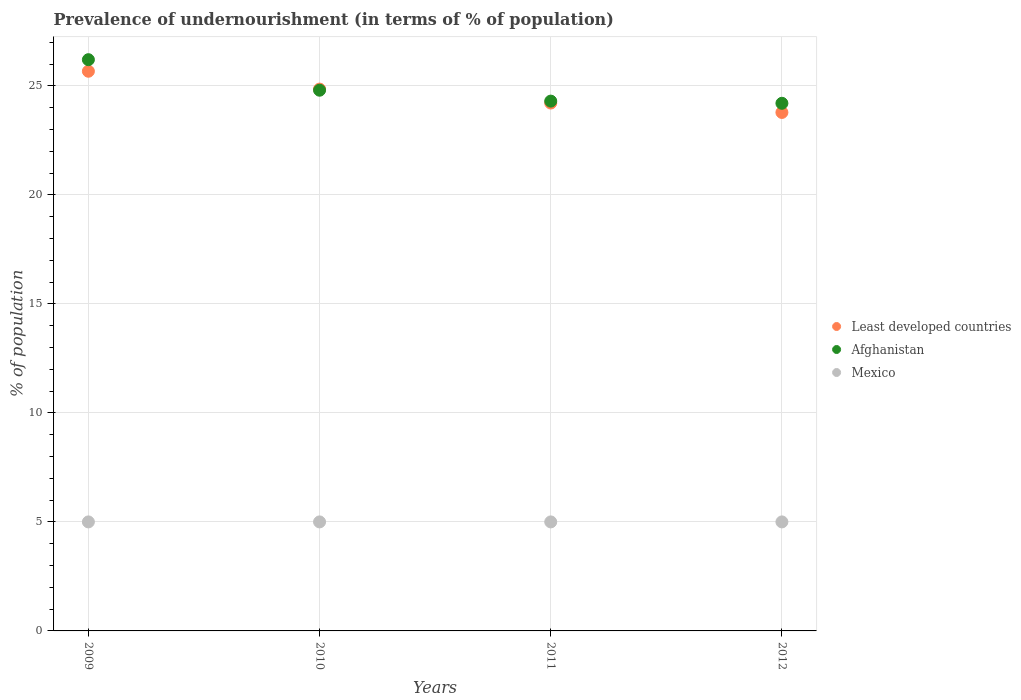How many different coloured dotlines are there?
Keep it short and to the point. 3. Is the number of dotlines equal to the number of legend labels?
Your answer should be very brief. Yes. Across all years, what is the maximum percentage of undernourished population in Mexico?
Make the answer very short. 5. Across all years, what is the minimum percentage of undernourished population in Least developed countries?
Provide a short and direct response. 23.78. In which year was the percentage of undernourished population in Mexico maximum?
Offer a terse response. 2009. In which year was the percentage of undernourished population in Afghanistan minimum?
Your answer should be very brief. 2012. What is the total percentage of undernourished population in Mexico in the graph?
Your answer should be compact. 20. What is the difference between the percentage of undernourished population in Mexico in 2009 and that in 2011?
Your response must be concise. 0. What is the difference between the percentage of undernourished population in Afghanistan in 2010 and the percentage of undernourished population in Least developed countries in 2009?
Offer a terse response. -0.87. What is the average percentage of undernourished population in Afghanistan per year?
Offer a terse response. 24.88. In the year 2009, what is the difference between the percentage of undernourished population in Afghanistan and percentage of undernourished population in Least developed countries?
Give a very brief answer. 0.53. In how many years, is the percentage of undernourished population in Mexico greater than 3 %?
Your answer should be very brief. 4. What is the ratio of the percentage of undernourished population in Afghanistan in 2011 to that in 2012?
Ensure brevity in your answer.  1. What is the difference between the highest and the second highest percentage of undernourished population in Least developed countries?
Offer a terse response. 0.82. What is the difference between the highest and the lowest percentage of undernourished population in Afghanistan?
Provide a succinct answer. 2. In how many years, is the percentage of undernourished population in Mexico greater than the average percentage of undernourished population in Mexico taken over all years?
Your answer should be compact. 0. Is it the case that in every year, the sum of the percentage of undernourished population in Least developed countries and percentage of undernourished population in Mexico  is greater than the percentage of undernourished population in Afghanistan?
Your response must be concise. Yes. Is the percentage of undernourished population in Mexico strictly greater than the percentage of undernourished population in Least developed countries over the years?
Offer a very short reply. No. How many years are there in the graph?
Provide a short and direct response. 4. Are the values on the major ticks of Y-axis written in scientific E-notation?
Ensure brevity in your answer.  No. Where does the legend appear in the graph?
Make the answer very short. Center right. How many legend labels are there?
Provide a succinct answer. 3. What is the title of the graph?
Offer a terse response. Prevalence of undernourishment (in terms of % of population). What is the label or title of the X-axis?
Offer a terse response. Years. What is the label or title of the Y-axis?
Provide a short and direct response. % of population. What is the % of population of Least developed countries in 2009?
Offer a terse response. 25.67. What is the % of population of Afghanistan in 2009?
Provide a succinct answer. 26.2. What is the % of population of Least developed countries in 2010?
Your response must be concise. 24.85. What is the % of population of Afghanistan in 2010?
Your answer should be compact. 24.8. What is the % of population in Mexico in 2010?
Offer a terse response. 5. What is the % of population of Least developed countries in 2011?
Give a very brief answer. 24.21. What is the % of population of Afghanistan in 2011?
Offer a terse response. 24.3. What is the % of population in Mexico in 2011?
Make the answer very short. 5. What is the % of population of Least developed countries in 2012?
Ensure brevity in your answer.  23.78. What is the % of population in Afghanistan in 2012?
Your response must be concise. 24.2. What is the % of population in Mexico in 2012?
Your answer should be compact. 5. Across all years, what is the maximum % of population of Least developed countries?
Provide a short and direct response. 25.67. Across all years, what is the maximum % of population of Afghanistan?
Your answer should be compact. 26.2. Across all years, what is the maximum % of population of Mexico?
Make the answer very short. 5. Across all years, what is the minimum % of population in Least developed countries?
Offer a terse response. 23.78. Across all years, what is the minimum % of population of Afghanistan?
Keep it short and to the point. 24.2. Across all years, what is the minimum % of population of Mexico?
Keep it short and to the point. 5. What is the total % of population in Least developed countries in the graph?
Provide a short and direct response. 98.51. What is the total % of population of Afghanistan in the graph?
Your response must be concise. 99.5. What is the difference between the % of population in Least developed countries in 2009 and that in 2010?
Provide a short and direct response. 0.82. What is the difference between the % of population in Afghanistan in 2009 and that in 2010?
Offer a very short reply. 1.4. What is the difference between the % of population of Least developed countries in 2009 and that in 2011?
Offer a terse response. 1.46. What is the difference between the % of population in Least developed countries in 2009 and that in 2012?
Your answer should be very brief. 1.89. What is the difference between the % of population in Afghanistan in 2009 and that in 2012?
Make the answer very short. 2. What is the difference between the % of population in Least developed countries in 2010 and that in 2011?
Keep it short and to the point. 0.64. What is the difference between the % of population of Mexico in 2010 and that in 2011?
Provide a succinct answer. 0. What is the difference between the % of population in Least developed countries in 2010 and that in 2012?
Make the answer very short. 1.07. What is the difference between the % of population of Least developed countries in 2011 and that in 2012?
Offer a very short reply. 0.43. What is the difference between the % of population of Mexico in 2011 and that in 2012?
Your answer should be compact. 0. What is the difference between the % of population in Least developed countries in 2009 and the % of population in Afghanistan in 2010?
Your answer should be compact. 0.87. What is the difference between the % of population of Least developed countries in 2009 and the % of population of Mexico in 2010?
Keep it short and to the point. 20.67. What is the difference between the % of population of Afghanistan in 2009 and the % of population of Mexico in 2010?
Offer a terse response. 21.2. What is the difference between the % of population of Least developed countries in 2009 and the % of population of Afghanistan in 2011?
Give a very brief answer. 1.37. What is the difference between the % of population of Least developed countries in 2009 and the % of population of Mexico in 2011?
Make the answer very short. 20.67. What is the difference between the % of population in Afghanistan in 2009 and the % of population in Mexico in 2011?
Provide a short and direct response. 21.2. What is the difference between the % of population in Least developed countries in 2009 and the % of population in Afghanistan in 2012?
Make the answer very short. 1.47. What is the difference between the % of population of Least developed countries in 2009 and the % of population of Mexico in 2012?
Provide a succinct answer. 20.67. What is the difference between the % of population of Afghanistan in 2009 and the % of population of Mexico in 2012?
Keep it short and to the point. 21.2. What is the difference between the % of population in Least developed countries in 2010 and the % of population in Afghanistan in 2011?
Provide a succinct answer. 0.55. What is the difference between the % of population of Least developed countries in 2010 and the % of population of Mexico in 2011?
Your answer should be compact. 19.85. What is the difference between the % of population of Afghanistan in 2010 and the % of population of Mexico in 2011?
Ensure brevity in your answer.  19.8. What is the difference between the % of population in Least developed countries in 2010 and the % of population in Afghanistan in 2012?
Give a very brief answer. 0.65. What is the difference between the % of population in Least developed countries in 2010 and the % of population in Mexico in 2012?
Provide a succinct answer. 19.85. What is the difference between the % of population of Afghanistan in 2010 and the % of population of Mexico in 2012?
Give a very brief answer. 19.8. What is the difference between the % of population in Least developed countries in 2011 and the % of population in Afghanistan in 2012?
Your answer should be very brief. 0.01. What is the difference between the % of population in Least developed countries in 2011 and the % of population in Mexico in 2012?
Your answer should be very brief. 19.21. What is the difference between the % of population of Afghanistan in 2011 and the % of population of Mexico in 2012?
Make the answer very short. 19.3. What is the average % of population in Least developed countries per year?
Provide a short and direct response. 24.63. What is the average % of population of Afghanistan per year?
Offer a very short reply. 24.88. In the year 2009, what is the difference between the % of population of Least developed countries and % of population of Afghanistan?
Your response must be concise. -0.53. In the year 2009, what is the difference between the % of population of Least developed countries and % of population of Mexico?
Make the answer very short. 20.67. In the year 2009, what is the difference between the % of population of Afghanistan and % of population of Mexico?
Provide a short and direct response. 21.2. In the year 2010, what is the difference between the % of population in Least developed countries and % of population in Afghanistan?
Keep it short and to the point. 0.05. In the year 2010, what is the difference between the % of population in Least developed countries and % of population in Mexico?
Provide a short and direct response. 19.85. In the year 2010, what is the difference between the % of population in Afghanistan and % of population in Mexico?
Offer a very short reply. 19.8. In the year 2011, what is the difference between the % of population of Least developed countries and % of population of Afghanistan?
Your response must be concise. -0.09. In the year 2011, what is the difference between the % of population of Least developed countries and % of population of Mexico?
Make the answer very short. 19.21. In the year 2011, what is the difference between the % of population of Afghanistan and % of population of Mexico?
Your response must be concise. 19.3. In the year 2012, what is the difference between the % of population of Least developed countries and % of population of Afghanistan?
Give a very brief answer. -0.42. In the year 2012, what is the difference between the % of population in Least developed countries and % of population in Mexico?
Make the answer very short. 18.78. What is the ratio of the % of population of Least developed countries in 2009 to that in 2010?
Offer a very short reply. 1.03. What is the ratio of the % of population of Afghanistan in 2009 to that in 2010?
Your answer should be very brief. 1.06. What is the ratio of the % of population of Mexico in 2009 to that in 2010?
Offer a terse response. 1. What is the ratio of the % of population of Least developed countries in 2009 to that in 2011?
Your answer should be very brief. 1.06. What is the ratio of the % of population in Afghanistan in 2009 to that in 2011?
Your answer should be compact. 1.08. What is the ratio of the % of population of Least developed countries in 2009 to that in 2012?
Provide a short and direct response. 1.08. What is the ratio of the % of population of Afghanistan in 2009 to that in 2012?
Make the answer very short. 1.08. What is the ratio of the % of population of Mexico in 2009 to that in 2012?
Provide a short and direct response. 1. What is the ratio of the % of population in Least developed countries in 2010 to that in 2011?
Your answer should be very brief. 1.03. What is the ratio of the % of population of Afghanistan in 2010 to that in 2011?
Your answer should be very brief. 1.02. What is the ratio of the % of population of Mexico in 2010 to that in 2011?
Keep it short and to the point. 1. What is the ratio of the % of population of Least developed countries in 2010 to that in 2012?
Give a very brief answer. 1.04. What is the ratio of the % of population in Afghanistan in 2010 to that in 2012?
Give a very brief answer. 1.02. What is the ratio of the % of population of Mexico in 2010 to that in 2012?
Give a very brief answer. 1. What is the ratio of the % of population of Least developed countries in 2011 to that in 2012?
Your response must be concise. 1.02. What is the ratio of the % of population of Afghanistan in 2011 to that in 2012?
Your response must be concise. 1. What is the difference between the highest and the second highest % of population of Least developed countries?
Your answer should be compact. 0.82. What is the difference between the highest and the lowest % of population in Least developed countries?
Your answer should be compact. 1.89. 